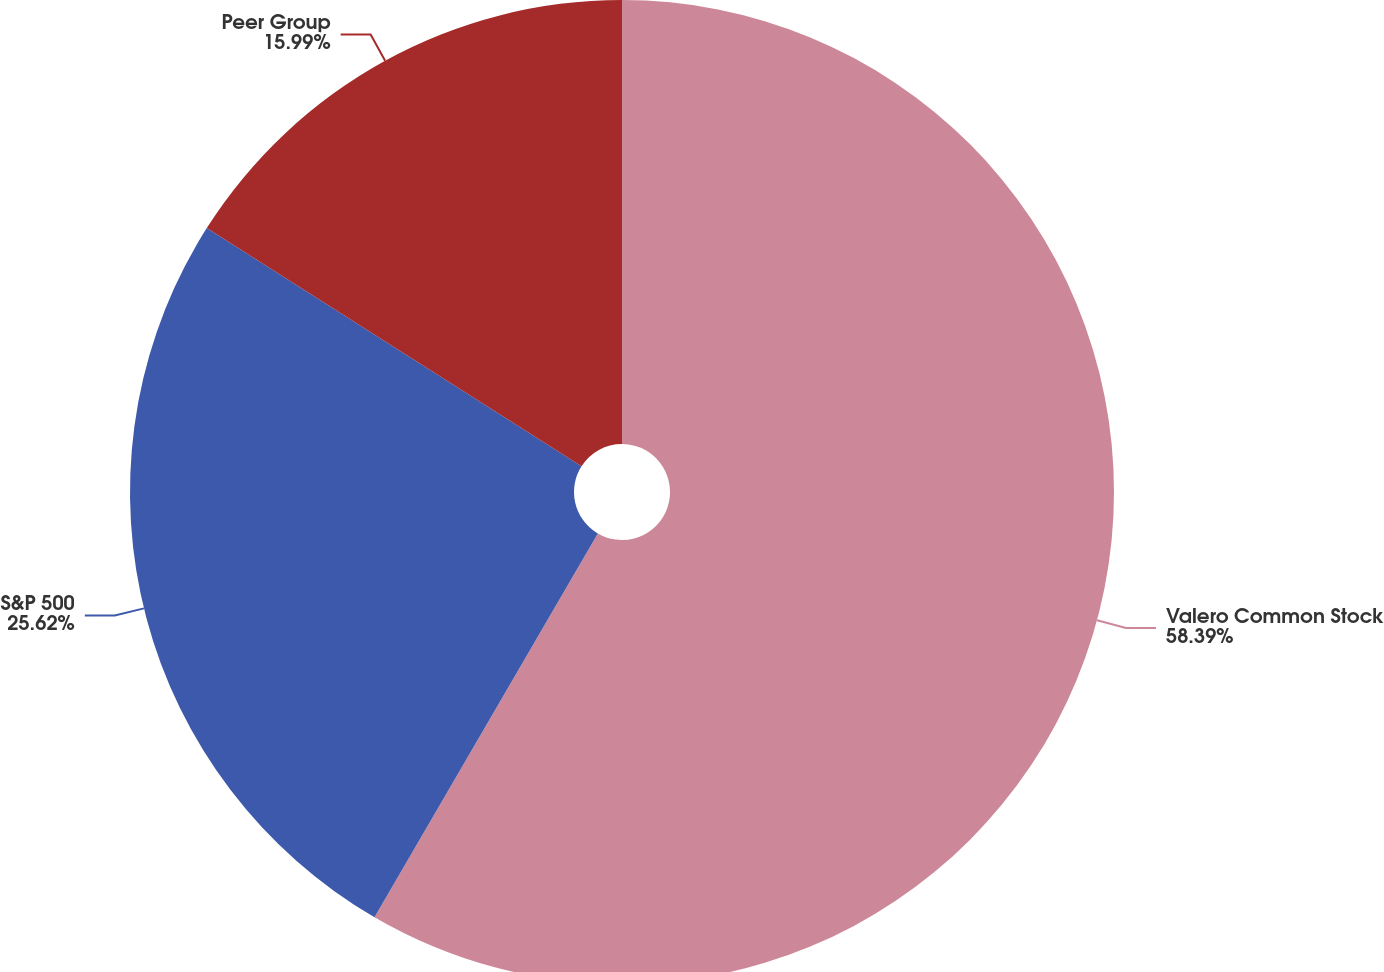<chart> <loc_0><loc_0><loc_500><loc_500><pie_chart><fcel>Valero Common Stock<fcel>S&P 500<fcel>Peer Group<nl><fcel>58.39%<fcel>25.62%<fcel>15.99%<nl></chart> 